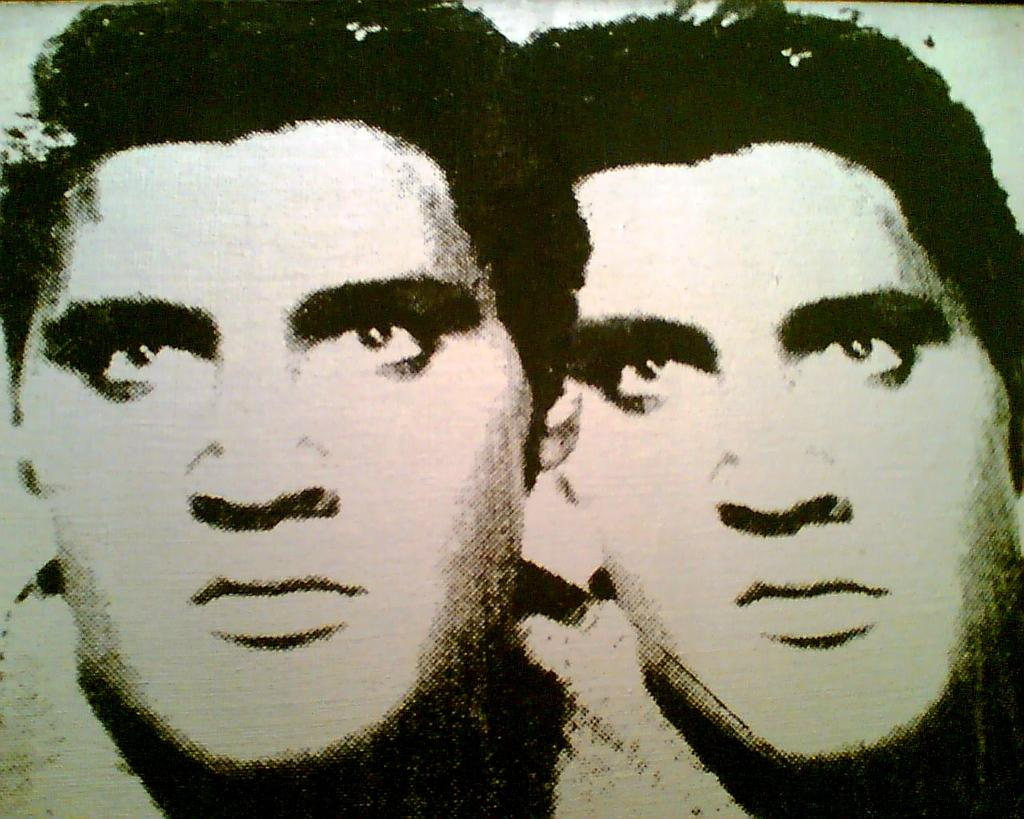What is the main subject of the image? There is a portrait in the image. How many faces are depicted in the portrait? The portrait contains two faces. What type of design can be seen on the book in the image? There is no book present in the image; it only contains a portrait with two faces. 